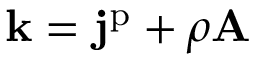<formula> <loc_0><loc_0><loc_500><loc_500>k = j ^ { p } + \rho A</formula> 